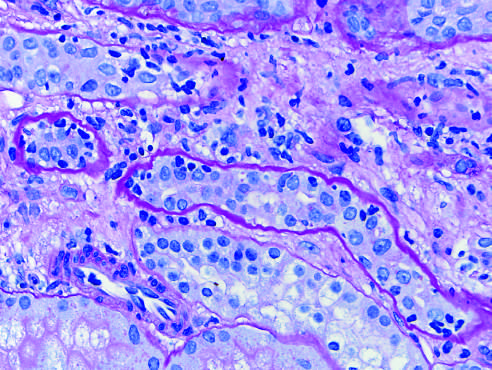re t_h17 cells in granuloma formation outlined by wavy basement membranes?
Answer the question using a single word or phrase. No 